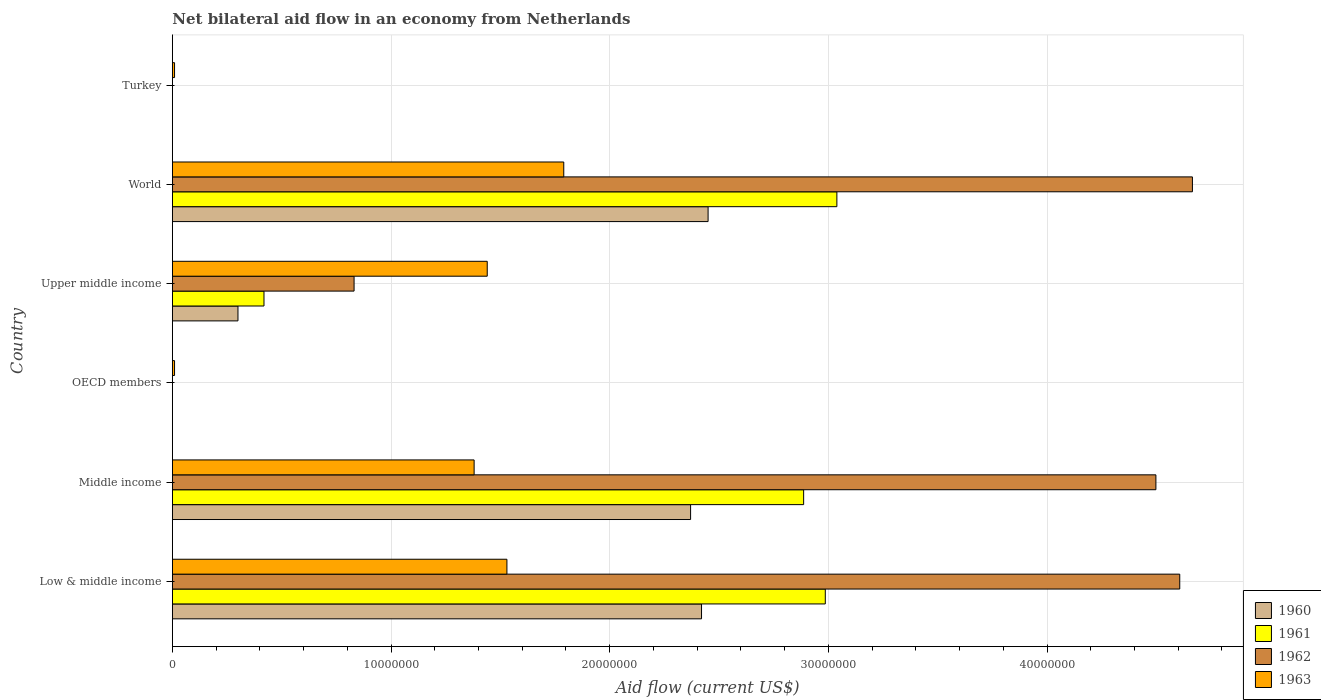How many different coloured bars are there?
Ensure brevity in your answer.  4. Are the number of bars per tick equal to the number of legend labels?
Your response must be concise. No. Are the number of bars on each tick of the Y-axis equal?
Ensure brevity in your answer.  No. How many bars are there on the 6th tick from the top?
Offer a very short reply. 4. How many bars are there on the 5th tick from the bottom?
Offer a very short reply. 4. In how many cases, is the number of bars for a given country not equal to the number of legend labels?
Your response must be concise. 2. What is the net bilateral aid flow in 1961 in Middle income?
Keep it short and to the point. 2.89e+07. Across all countries, what is the maximum net bilateral aid flow in 1961?
Your response must be concise. 3.04e+07. In which country was the net bilateral aid flow in 1961 maximum?
Provide a succinct answer. World. What is the total net bilateral aid flow in 1962 in the graph?
Provide a succinct answer. 1.46e+08. What is the difference between the net bilateral aid flow in 1962 in Middle income and that in World?
Offer a terse response. -1.67e+06. What is the difference between the net bilateral aid flow in 1961 in Middle income and the net bilateral aid flow in 1962 in Low & middle income?
Offer a terse response. -1.72e+07. What is the average net bilateral aid flow in 1962 per country?
Ensure brevity in your answer.  2.43e+07. What is the difference between the net bilateral aid flow in 1961 and net bilateral aid flow in 1962 in Low & middle income?
Make the answer very short. -1.62e+07. In how many countries, is the net bilateral aid flow in 1962 greater than 14000000 US$?
Your response must be concise. 3. What is the ratio of the net bilateral aid flow in 1961 in Middle income to that in Upper middle income?
Your answer should be very brief. 6.89. Is the net bilateral aid flow in 1963 in Middle income less than that in World?
Provide a short and direct response. Yes. What is the difference between the highest and the second highest net bilateral aid flow in 1960?
Give a very brief answer. 3.00e+05. What is the difference between the highest and the lowest net bilateral aid flow in 1961?
Your answer should be compact. 3.04e+07. In how many countries, is the net bilateral aid flow in 1962 greater than the average net bilateral aid flow in 1962 taken over all countries?
Make the answer very short. 3. How many bars are there?
Offer a terse response. 18. What is the difference between two consecutive major ticks on the X-axis?
Keep it short and to the point. 1.00e+07. Does the graph contain any zero values?
Provide a succinct answer. Yes. Does the graph contain grids?
Keep it short and to the point. Yes. How many legend labels are there?
Give a very brief answer. 4. What is the title of the graph?
Your answer should be compact. Net bilateral aid flow in an economy from Netherlands. What is the label or title of the X-axis?
Make the answer very short. Aid flow (current US$). What is the label or title of the Y-axis?
Your response must be concise. Country. What is the Aid flow (current US$) in 1960 in Low & middle income?
Your answer should be compact. 2.42e+07. What is the Aid flow (current US$) in 1961 in Low & middle income?
Your answer should be very brief. 2.99e+07. What is the Aid flow (current US$) of 1962 in Low & middle income?
Provide a short and direct response. 4.61e+07. What is the Aid flow (current US$) of 1963 in Low & middle income?
Offer a very short reply. 1.53e+07. What is the Aid flow (current US$) of 1960 in Middle income?
Keep it short and to the point. 2.37e+07. What is the Aid flow (current US$) of 1961 in Middle income?
Ensure brevity in your answer.  2.89e+07. What is the Aid flow (current US$) in 1962 in Middle income?
Provide a succinct answer. 4.50e+07. What is the Aid flow (current US$) in 1963 in Middle income?
Provide a short and direct response. 1.38e+07. What is the Aid flow (current US$) in 1961 in OECD members?
Your response must be concise. 0. What is the Aid flow (current US$) in 1962 in OECD members?
Your response must be concise. 0. What is the Aid flow (current US$) in 1963 in OECD members?
Your answer should be compact. 1.00e+05. What is the Aid flow (current US$) in 1960 in Upper middle income?
Your response must be concise. 3.00e+06. What is the Aid flow (current US$) of 1961 in Upper middle income?
Give a very brief answer. 4.19e+06. What is the Aid flow (current US$) of 1962 in Upper middle income?
Your answer should be compact. 8.31e+06. What is the Aid flow (current US$) of 1963 in Upper middle income?
Keep it short and to the point. 1.44e+07. What is the Aid flow (current US$) of 1960 in World?
Give a very brief answer. 2.45e+07. What is the Aid flow (current US$) in 1961 in World?
Make the answer very short. 3.04e+07. What is the Aid flow (current US$) in 1962 in World?
Give a very brief answer. 4.66e+07. What is the Aid flow (current US$) in 1963 in World?
Offer a terse response. 1.79e+07. What is the Aid flow (current US$) in 1961 in Turkey?
Make the answer very short. 0. Across all countries, what is the maximum Aid flow (current US$) in 1960?
Ensure brevity in your answer.  2.45e+07. Across all countries, what is the maximum Aid flow (current US$) of 1961?
Give a very brief answer. 3.04e+07. Across all countries, what is the maximum Aid flow (current US$) in 1962?
Offer a very short reply. 4.66e+07. Across all countries, what is the maximum Aid flow (current US$) in 1963?
Your answer should be very brief. 1.79e+07. Across all countries, what is the minimum Aid flow (current US$) of 1961?
Provide a short and direct response. 0. What is the total Aid flow (current US$) in 1960 in the graph?
Give a very brief answer. 7.54e+07. What is the total Aid flow (current US$) of 1961 in the graph?
Your response must be concise. 9.33e+07. What is the total Aid flow (current US$) in 1962 in the graph?
Your answer should be compact. 1.46e+08. What is the total Aid flow (current US$) of 1963 in the graph?
Provide a short and direct response. 6.16e+07. What is the difference between the Aid flow (current US$) of 1961 in Low & middle income and that in Middle income?
Your response must be concise. 9.90e+05. What is the difference between the Aid flow (current US$) of 1962 in Low & middle income and that in Middle income?
Keep it short and to the point. 1.09e+06. What is the difference between the Aid flow (current US$) of 1963 in Low & middle income and that in Middle income?
Offer a very short reply. 1.50e+06. What is the difference between the Aid flow (current US$) of 1963 in Low & middle income and that in OECD members?
Provide a short and direct response. 1.52e+07. What is the difference between the Aid flow (current US$) in 1960 in Low & middle income and that in Upper middle income?
Your answer should be very brief. 2.12e+07. What is the difference between the Aid flow (current US$) in 1961 in Low & middle income and that in Upper middle income?
Make the answer very short. 2.57e+07. What is the difference between the Aid flow (current US$) of 1962 in Low & middle income and that in Upper middle income?
Give a very brief answer. 3.78e+07. What is the difference between the Aid flow (current US$) of 1960 in Low & middle income and that in World?
Provide a short and direct response. -3.00e+05. What is the difference between the Aid flow (current US$) in 1961 in Low & middle income and that in World?
Offer a terse response. -5.30e+05. What is the difference between the Aid flow (current US$) in 1962 in Low & middle income and that in World?
Your answer should be very brief. -5.80e+05. What is the difference between the Aid flow (current US$) in 1963 in Low & middle income and that in World?
Give a very brief answer. -2.60e+06. What is the difference between the Aid flow (current US$) of 1963 in Low & middle income and that in Turkey?
Your answer should be very brief. 1.52e+07. What is the difference between the Aid flow (current US$) of 1963 in Middle income and that in OECD members?
Ensure brevity in your answer.  1.37e+07. What is the difference between the Aid flow (current US$) in 1960 in Middle income and that in Upper middle income?
Offer a terse response. 2.07e+07. What is the difference between the Aid flow (current US$) of 1961 in Middle income and that in Upper middle income?
Ensure brevity in your answer.  2.47e+07. What is the difference between the Aid flow (current US$) in 1962 in Middle income and that in Upper middle income?
Make the answer very short. 3.67e+07. What is the difference between the Aid flow (current US$) of 1963 in Middle income and that in Upper middle income?
Keep it short and to the point. -6.00e+05. What is the difference between the Aid flow (current US$) in 1960 in Middle income and that in World?
Offer a terse response. -8.00e+05. What is the difference between the Aid flow (current US$) of 1961 in Middle income and that in World?
Your answer should be compact. -1.52e+06. What is the difference between the Aid flow (current US$) of 1962 in Middle income and that in World?
Provide a succinct answer. -1.67e+06. What is the difference between the Aid flow (current US$) of 1963 in Middle income and that in World?
Offer a terse response. -4.10e+06. What is the difference between the Aid flow (current US$) in 1963 in Middle income and that in Turkey?
Offer a terse response. 1.37e+07. What is the difference between the Aid flow (current US$) of 1963 in OECD members and that in Upper middle income?
Offer a terse response. -1.43e+07. What is the difference between the Aid flow (current US$) in 1963 in OECD members and that in World?
Keep it short and to the point. -1.78e+07. What is the difference between the Aid flow (current US$) in 1963 in OECD members and that in Turkey?
Offer a terse response. 0. What is the difference between the Aid flow (current US$) of 1960 in Upper middle income and that in World?
Provide a succinct answer. -2.15e+07. What is the difference between the Aid flow (current US$) in 1961 in Upper middle income and that in World?
Provide a succinct answer. -2.62e+07. What is the difference between the Aid flow (current US$) in 1962 in Upper middle income and that in World?
Give a very brief answer. -3.83e+07. What is the difference between the Aid flow (current US$) of 1963 in Upper middle income and that in World?
Provide a succinct answer. -3.50e+06. What is the difference between the Aid flow (current US$) in 1963 in Upper middle income and that in Turkey?
Make the answer very short. 1.43e+07. What is the difference between the Aid flow (current US$) of 1963 in World and that in Turkey?
Make the answer very short. 1.78e+07. What is the difference between the Aid flow (current US$) of 1960 in Low & middle income and the Aid flow (current US$) of 1961 in Middle income?
Provide a succinct answer. -4.67e+06. What is the difference between the Aid flow (current US$) in 1960 in Low & middle income and the Aid flow (current US$) in 1962 in Middle income?
Offer a very short reply. -2.08e+07. What is the difference between the Aid flow (current US$) of 1960 in Low & middle income and the Aid flow (current US$) of 1963 in Middle income?
Offer a terse response. 1.04e+07. What is the difference between the Aid flow (current US$) in 1961 in Low & middle income and the Aid flow (current US$) in 1962 in Middle income?
Make the answer very short. -1.51e+07. What is the difference between the Aid flow (current US$) of 1961 in Low & middle income and the Aid flow (current US$) of 1963 in Middle income?
Provide a succinct answer. 1.61e+07. What is the difference between the Aid flow (current US$) in 1962 in Low & middle income and the Aid flow (current US$) in 1963 in Middle income?
Your response must be concise. 3.23e+07. What is the difference between the Aid flow (current US$) in 1960 in Low & middle income and the Aid flow (current US$) in 1963 in OECD members?
Offer a terse response. 2.41e+07. What is the difference between the Aid flow (current US$) in 1961 in Low & middle income and the Aid flow (current US$) in 1963 in OECD members?
Your answer should be compact. 2.98e+07. What is the difference between the Aid flow (current US$) of 1962 in Low & middle income and the Aid flow (current US$) of 1963 in OECD members?
Offer a very short reply. 4.60e+07. What is the difference between the Aid flow (current US$) of 1960 in Low & middle income and the Aid flow (current US$) of 1961 in Upper middle income?
Give a very brief answer. 2.00e+07. What is the difference between the Aid flow (current US$) of 1960 in Low & middle income and the Aid flow (current US$) of 1962 in Upper middle income?
Give a very brief answer. 1.59e+07. What is the difference between the Aid flow (current US$) of 1960 in Low & middle income and the Aid flow (current US$) of 1963 in Upper middle income?
Your answer should be compact. 9.80e+06. What is the difference between the Aid flow (current US$) in 1961 in Low & middle income and the Aid flow (current US$) in 1962 in Upper middle income?
Offer a very short reply. 2.16e+07. What is the difference between the Aid flow (current US$) in 1961 in Low & middle income and the Aid flow (current US$) in 1963 in Upper middle income?
Provide a succinct answer. 1.55e+07. What is the difference between the Aid flow (current US$) in 1962 in Low & middle income and the Aid flow (current US$) in 1963 in Upper middle income?
Provide a short and direct response. 3.17e+07. What is the difference between the Aid flow (current US$) in 1960 in Low & middle income and the Aid flow (current US$) in 1961 in World?
Keep it short and to the point. -6.19e+06. What is the difference between the Aid flow (current US$) in 1960 in Low & middle income and the Aid flow (current US$) in 1962 in World?
Provide a succinct answer. -2.24e+07. What is the difference between the Aid flow (current US$) of 1960 in Low & middle income and the Aid flow (current US$) of 1963 in World?
Offer a terse response. 6.30e+06. What is the difference between the Aid flow (current US$) of 1961 in Low & middle income and the Aid flow (current US$) of 1962 in World?
Your answer should be very brief. -1.68e+07. What is the difference between the Aid flow (current US$) of 1961 in Low & middle income and the Aid flow (current US$) of 1963 in World?
Provide a succinct answer. 1.20e+07. What is the difference between the Aid flow (current US$) of 1962 in Low & middle income and the Aid flow (current US$) of 1963 in World?
Make the answer very short. 2.82e+07. What is the difference between the Aid flow (current US$) in 1960 in Low & middle income and the Aid flow (current US$) in 1963 in Turkey?
Give a very brief answer. 2.41e+07. What is the difference between the Aid flow (current US$) in 1961 in Low & middle income and the Aid flow (current US$) in 1963 in Turkey?
Make the answer very short. 2.98e+07. What is the difference between the Aid flow (current US$) in 1962 in Low & middle income and the Aid flow (current US$) in 1963 in Turkey?
Give a very brief answer. 4.60e+07. What is the difference between the Aid flow (current US$) in 1960 in Middle income and the Aid flow (current US$) in 1963 in OECD members?
Give a very brief answer. 2.36e+07. What is the difference between the Aid flow (current US$) of 1961 in Middle income and the Aid flow (current US$) of 1963 in OECD members?
Provide a short and direct response. 2.88e+07. What is the difference between the Aid flow (current US$) of 1962 in Middle income and the Aid flow (current US$) of 1963 in OECD members?
Ensure brevity in your answer.  4.49e+07. What is the difference between the Aid flow (current US$) of 1960 in Middle income and the Aid flow (current US$) of 1961 in Upper middle income?
Keep it short and to the point. 1.95e+07. What is the difference between the Aid flow (current US$) of 1960 in Middle income and the Aid flow (current US$) of 1962 in Upper middle income?
Your answer should be compact. 1.54e+07. What is the difference between the Aid flow (current US$) of 1960 in Middle income and the Aid flow (current US$) of 1963 in Upper middle income?
Ensure brevity in your answer.  9.30e+06. What is the difference between the Aid flow (current US$) in 1961 in Middle income and the Aid flow (current US$) in 1962 in Upper middle income?
Give a very brief answer. 2.06e+07. What is the difference between the Aid flow (current US$) in 1961 in Middle income and the Aid flow (current US$) in 1963 in Upper middle income?
Give a very brief answer. 1.45e+07. What is the difference between the Aid flow (current US$) of 1962 in Middle income and the Aid flow (current US$) of 1963 in Upper middle income?
Provide a short and direct response. 3.06e+07. What is the difference between the Aid flow (current US$) in 1960 in Middle income and the Aid flow (current US$) in 1961 in World?
Your answer should be very brief. -6.69e+06. What is the difference between the Aid flow (current US$) of 1960 in Middle income and the Aid flow (current US$) of 1962 in World?
Keep it short and to the point. -2.30e+07. What is the difference between the Aid flow (current US$) of 1960 in Middle income and the Aid flow (current US$) of 1963 in World?
Offer a terse response. 5.80e+06. What is the difference between the Aid flow (current US$) of 1961 in Middle income and the Aid flow (current US$) of 1962 in World?
Provide a succinct answer. -1.78e+07. What is the difference between the Aid flow (current US$) of 1961 in Middle income and the Aid flow (current US$) of 1963 in World?
Your response must be concise. 1.10e+07. What is the difference between the Aid flow (current US$) of 1962 in Middle income and the Aid flow (current US$) of 1963 in World?
Offer a terse response. 2.71e+07. What is the difference between the Aid flow (current US$) of 1960 in Middle income and the Aid flow (current US$) of 1963 in Turkey?
Make the answer very short. 2.36e+07. What is the difference between the Aid flow (current US$) in 1961 in Middle income and the Aid flow (current US$) in 1963 in Turkey?
Your answer should be very brief. 2.88e+07. What is the difference between the Aid flow (current US$) of 1962 in Middle income and the Aid flow (current US$) of 1963 in Turkey?
Your response must be concise. 4.49e+07. What is the difference between the Aid flow (current US$) of 1960 in Upper middle income and the Aid flow (current US$) of 1961 in World?
Give a very brief answer. -2.74e+07. What is the difference between the Aid flow (current US$) in 1960 in Upper middle income and the Aid flow (current US$) in 1962 in World?
Ensure brevity in your answer.  -4.36e+07. What is the difference between the Aid flow (current US$) of 1960 in Upper middle income and the Aid flow (current US$) of 1963 in World?
Your answer should be compact. -1.49e+07. What is the difference between the Aid flow (current US$) of 1961 in Upper middle income and the Aid flow (current US$) of 1962 in World?
Give a very brief answer. -4.25e+07. What is the difference between the Aid flow (current US$) of 1961 in Upper middle income and the Aid flow (current US$) of 1963 in World?
Your answer should be very brief. -1.37e+07. What is the difference between the Aid flow (current US$) of 1962 in Upper middle income and the Aid flow (current US$) of 1963 in World?
Provide a succinct answer. -9.59e+06. What is the difference between the Aid flow (current US$) in 1960 in Upper middle income and the Aid flow (current US$) in 1963 in Turkey?
Provide a succinct answer. 2.90e+06. What is the difference between the Aid flow (current US$) of 1961 in Upper middle income and the Aid flow (current US$) of 1963 in Turkey?
Your answer should be very brief. 4.09e+06. What is the difference between the Aid flow (current US$) of 1962 in Upper middle income and the Aid flow (current US$) of 1963 in Turkey?
Your answer should be very brief. 8.21e+06. What is the difference between the Aid flow (current US$) in 1960 in World and the Aid flow (current US$) in 1963 in Turkey?
Provide a short and direct response. 2.44e+07. What is the difference between the Aid flow (current US$) in 1961 in World and the Aid flow (current US$) in 1963 in Turkey?
Your answer should be very brief. 3.03e+07. What is the difference between the Aid flow (current US$) of 1962 in World and the Aid flow (current US$) of 1963 in Turkey?
Offer a very short reply. 4.66e+07. What is the average Aid flow (current US$) of 1960 per country?
Offer a terse response. 1.26e+07. What is the average Aid flow (current US$) of 1961 per country?
Offer a terse response. 1.56e+07. What is the average Aid flow (current US$) of 1962 per country?
Provide a short and direct response. 2.43e+07. What is the average Aid flow (current US$) of 1963 per country?
Make the answer very short. 1.03e+07. What is the difference between the Aid flow (current US$) in 1960 and Aid flow (current US$) in 1961 in Low & middle income?
Provide a short and direct response. -5.66e+06. What is the difference between the Aid flow (current US$) of 1960 and Aid flow (current US$) of 1962 in Low & middle income?
Ensure brevity in your answer.  -2.19e+07. What is the difference between the Aid flow (current US$) in 1960 and Aid flow (current US$) in 1963 in Low & middle income?
Give a very brief answer. 8.90e+06. What is the difference between the Aid flow (current US$) of 1961 and Aid flow (current US$) of 1962 in Low & middle income?
Provide a succinct answer. -1.62e+07. What is the difference between the Aid flow (current US$) in 1961 and Aid flow (current US$) in 1963 in Low & middle income?
Your answer should be very brief. 1.46e+07. What is the difference between the Aid flow (current US$) of 1962 and Aid flow (current US$) of 1963 in Low & middle income?
Your response must be concise. 3.08e+07. What is the difference between the Aid flow (current US$) in 1960 and Aid flow (current US$) in 1961 in Middle income?
Provide a short and direct response. -5.17e+06. What is the difference between the Aid flow (current US$) in 1960 and Aid flow (current US$) in 1962 in Middle income?
Keep it short and to the point. -2.13e+07. What is the difference between the Aid flow (current US$) of 1960 and Aid flow (current US$) of 1963 in Middle income?
Your response must be concise. 9.90e+06. What is the difference between the Aid flow (current US$) in 1961 and Aid flow (current US$) in 1962 in Middle income?
Make the answer very short. -1.61e+07. What is the difference between the Aid flow (current US$) of 1961 and Aid flow (current US$) of 1963 in Middle income?
Keep it short and to the point. 1.51e+07. What is the difference between the Aid flow (current US$) of 1962 and Aid flow (current US$) of 1963 in Middle income?
Make the answer very short. 3.12e+07. What is the difference between the Aid flow (current US$) in 1960 and Aid flow (current US$) in 1961 in Upper middle income?
Provide a short and direct response. -1.19e+06. What is the difference between the Aid flow (current US$) in 1960 and Aid flow (current US$) in 1962 in Upper middle income?
Make the answer very short. -5.31e+06. What is the difference between the Aid flow (current US$) in 1960 and Aid flow (current US$) in 1963 in Upper middle income?
Your response must be concise. -1.14e+07. What is the difference between the Aid flow (current US$) of 1961 and Aid flow (current US$) of 1962 in Upper middle income?
Your response must be concise. -4.12e+06. What is the difference between the Aid flow (current US$) in 1961 and Aid flow (current US$) in 1963 in Upper middle income?
Your answer should be very brief. -1.02e+07. What is the difference between the Aid flow (current US$) of 1962 and Aid flow (current US$) of 1963 in Upper middle income?
Make the answer very short. -6.09e+06. What is the difference between the Aid flow (current US$) of 1960 and Aid flow (current US$) of 1961 in World?
Your response must be concise. -5.89e+06. What is the difference between the Aid flow (current US$) of 1960 and Aid flow (current US$) of 1962 in World?
Your answer should be compact. -2.22e+07. What is the difference between the Aid flow (current US$) of 1960 and Aid flow (current US$) of 1963 in World?
Provide a succinct answer. 6.60e+06. What is the difference between the Aid flow (current US$) in 1961 and Aid flow (current US$) in 1962 in World?
Provide a short and direct response. -1.63e+07. What is the difference between the Aid flow (current US$) of 1961 and Aid flow (current US$) of 1963 in World?
Provide a succinct answer. 1.25e+07. What is the difference between the Aid flow (current US$) of 1962 and Aid flow (current US$) of 1963 in World?
Keep it short and to the point. 2.88e+07. What is the ratio of the Aid flow (current US$) in 1960 in Low & middle income to that in Middle income?
Provide a succinct answer. 1.02. What is the ratio of the Aid flow (current US$) in 1961 in Low & middle income to that in Middle income?
Make the answer very short. 1.03. What is the ratio of the Aid flow (current US$) of 1962 in Low & middle income to that in Middle income?
Keep it short and to the point. 1.02. What is the ratio of the Aid flow (current US$) in 1963 in Low & middle income to that in Middle income?
Your response must be concise. 1.11. What is the ratio of the Aid flow (current US$) of 1963 in Low & middle income to that in OECD members?
Ensure brevity in your answer.  153. What is the ratio of the Aid flow (current US$) of 1960 in Low & middle income to that in Upper middle income?
Keep it short and to the point. 8.07. What is the ratio of the Aid flow (current US$) of 1961 in Low & middle income to that in Upper middle income?
Make the answer very short. 7.13. What is the ratio of the Aid flow (current US$) in 1962 in Low & middle income to that in Upper middle income?
Your answer should be compact. 5.54. What is the ratio of the Aid flow (current US$) of 1961 in Low & middle income to that in World?
Make the answer very short. 0.98. What is the ratio of the Aid flow (current US$) of 1962 in Low & middle income to that in World?
Keep it short and to the point. 0.99. What is the ratio of the Aid flow (current US$) of 1963 in Low & middle income to that in World?
Give a very brief answer. 0.85. What is the ratio of the Aid flow (current US$) in 1963 in Low & middle income to that in Turkey?
Ensure brevity in your answer.  153. What is the ratio of the Aid flow (current US$) in 1963 in Middle income to that in OECD members?
Your response must be concise. 138. What is the ratio of the Aid flow (current US$) in 1960 in Middle income to that in Upper middle income?
Offer a terse response. 7.9. What is the ratio of the Aid flow (current US$) in 1961 in Middle income to that in Upper middle income?
Your response must be concise. 6.89. What is the ratio of the Aid flow (current US$) in 1962 in Middle income to that in Upper middle income?
Ensure brevity in your answer.  5.41. What is the ratio of the Aid flow (current US$) of 1960 in Middle income to that in World?
Make the answer very short. 0.97. What is the ratio of the Aid flow (current US$) in 1961 in Middle income to that in World?
Your response must be concise. 0.95. What is the ratio of the Aid flow (current US$) of 1962 in Middle income to that in World?
Provide a succinct answer. 0.96. What is the ratio of the Aid flow (current US$) of 1963 in Middle income to that in World?
Give a very brief answer. 0.77. What is the ratio of the Aid flow (current US$) in 1963 in Middle income to that in Turkey?
Provide a short and direct response. 138. What is the ratio of the Aid flow (current US$) of 1963 in OECD members to that in Upper middle income?
Offer a very short reply. 0.01. What is the ratio of the Aid flow (current US$) in 1963 in OECD members to that in World?
Provide a short and direct response. 0.01. What is the ratio of the Aid flow (current US$) in 1963 in OECD members to that in Turkey?
Offer a terse response. 1. What is the ratio of the Aid flow (current US$) in 1960 in Upper middle income to that in World?
Offer a very short reply. 0.12. What is the ratio of the Aid flow (current US$) in 1961 in Upper middle income to that in World?
Your answer should be compact. 0.14. What is the ratio of the Aid flow (current US$) in 1962 in Upper middle income to that in World?
Make the answer very short. 0.18. What is the ratio of the Aid flow (current US$) in 1963 in Upper middle income to that in World?
Your answer should be very brief. 0.8. What is the ratio of the Aid flow (current US$) in 1963 in Upper middle income to that in Turkey?
Your response must be concise. 144. What is the ratio of the Aid flow (current US$) in 1963 in World to that in Turkey?
Your answer should be very brief. 179. What is the difference between the highest and the second highest Aid flow (current US$) of 1960?
Ensure brevity in your answer.  3.00e+05. What is the difference between the highest and the second highest Aid flow (current US$) in 1961?
Make the answer very short. 5.30e+05. What is the difference between the highest and the second highest Aid flow (current US$) of 1962?
Provide a short and direct response. 5.80e+05. What is the difference between the highest and the second highest Aid flow (current US$) of 1963?
Your response must be concise. 2.60e+06. What is the difference between the highest and the lowest Aid flow (current US$) in 1960?
Provide a short and direct response. 2.45e+07. What is the difference between the highest and the lowest Aid flow (current US$) of 1961?
Your answer should be very brief. 3.04e+07. What is the difference between the highest and the lowest Aid flow (current US$) in 1962?
Your response must be concise. 4.66e+07. What is the difference between the highest and the lowest Aid flow (current US$) in 1963?
Your response must be concise. 1.78e+07. 